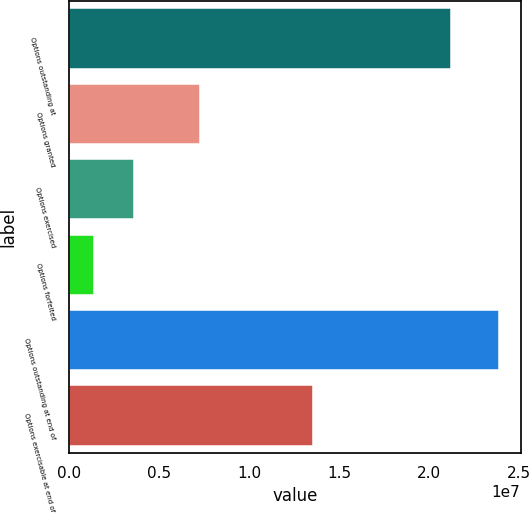<chart> <loc_0><loc_0><loc_500><loc_500><bar_chart><fcel>Options outstanding at<fcel>Options granted<fcel>Options exercised<fcel>Options forfeited<fcel>Options outstanding at end of<fcel>Options exercisable at end of<nl><fcel>2.11838e+07<fcel>7.26951e+06<fcel>3.62851e+06<fcel>1.37909e+06<fcel>2.38733e+07<fcel>1.35696e+07<nl></chart> 